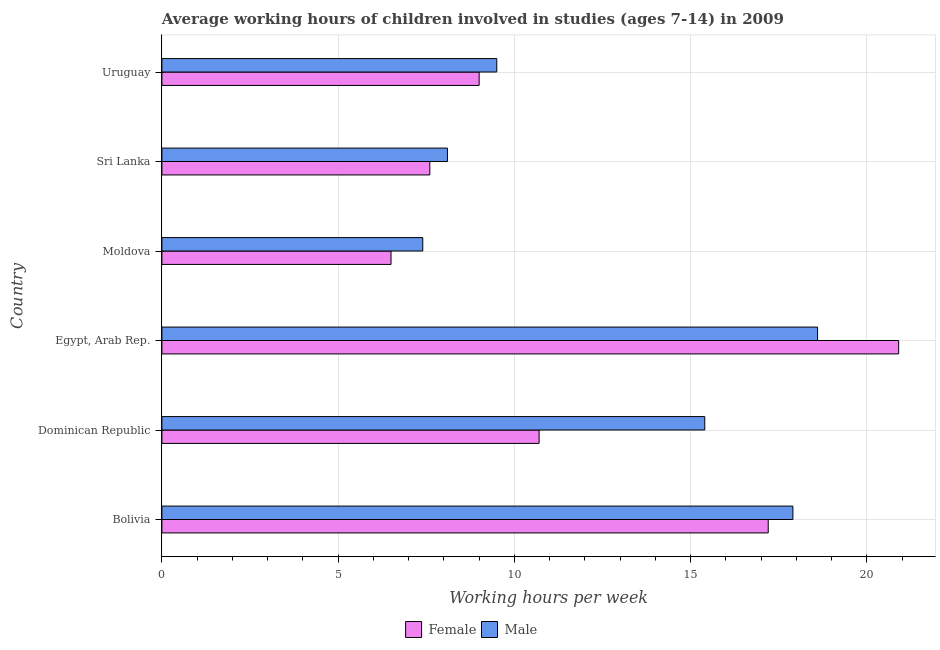How many different coloured bars are there?
Your answer should be compact. 2. Are the number of bars on each tick of the Y-axis equal?
Offer a terse response. Yes. What is the label of the 1st group of bars from the top?
Your answer should be compact. Uruguay. In how many cases, is the number of bars for a given country not equal to the number of legend labels?
Give a very brief answer. 0. Across all countries, what is the maximum average working hour of male children?
Give a very brief answer. 18.6. In which country was the average working hour of male children maximum?
Provide a succinct answer. Egypt, Arab Rep. In which country was the average working hour of female children minimum?
Your response must be concise. Moldova. What is the total average working hour of male children in the graph?
Your answer should be very brief. 76.9. What is the difference between the average working hour of male children in Dominican Republic and the average working hour of female children in Uruguay?
Keep it short and to the point. 6.4. What is the average average working hour of male children per country?
Your answer should be compact. 12.82. What is the difference between the average working hour of male children and average working hour of female children in Bolivia?
Offer a very short reply. 0.7. What is the ratio of the average working hour of male children in Moldova to that in Uruguay?
Your answer should be very brief. 0.78. What is the difference between the highest and the lowest average working hour of male children?
Your answer should be compact. 11.2. Is the sum of the average working hour of female children in Egypt, Arab Rep. and Moldova greater than the maximum average working hour of male children across all countries?
Ensure brevity in your answer.  Yes. What does the 2nd bar from the bottom in Egypt, Arab Rep. represents?
Your answer should be compact. Male. How many bars are there?
Your answer should be very brief. 12. How many countries are there in the graph?
Offer a very short reply. 6. What is the difference between two consecutive major ticks on the X-axis?
Ensure brevity in your answer.  5. Does the graph contain any zero values?
Your answer should be compact. No. Does the graph contain grids?
Your response must be concise. Yes. How many legend labels are there?
Make the answer very short. 2. What is the title of the graph?
Provide a succinct answer. Average working hours of children involved in studies (ages 7-14) in 2009. What is the label or title of the X-axis?
Your answer should be very brief. Working hours per week. What is the Working hours per week in Female in Bolivia?
Make the answer very short. 17.2. What is the Working hours per week in Female in Dominican Republic?
Provide a short and direct response. 10.7. What is the Working hours per week of Female in Egypt, Arab Rep.?
Keep it short and to the point. 20.9. What is the Working hours per week in Male in Egypt, Arab Rep.?
Provide a short and direct response. 18.6. What is the Working hours per week of Female in Moldova?
Your answer should be compact. 6.5. What is the Working hours per week in Male in Uruguay?
Your response must be concise. 9.5. Across all countries, what is the maximum Working hours per week of Female?
Give a very brief answer. 20.9. Across all countries, what is the maximum Working hours per week in Male?
Ensure brevity in your answer.  18.6. What is the total Working hours per week of Female in the graph?
Your answer should be compact. 71.9. What is the total Working hours per week of Male in the graph?
Provide a short and direct response. 76.9. What is the difference between the Working hours per week of Male in Bolivia and that in Dominican Republic?
Make the answer very short. 2.5. What is the difference between the Working hours per week of Female in Bolivia and that in Egypt, Arab Rep.?
Provide a succinct answer. -3.7. What is the difference between the Working hours per week of Male in Bolivia and that in Moldova?
Offer a terse response. 10.5. What is the difference between the Working hours per week in Female in Bolivia and that in Sri Lanka?
Ensure brevity in your answer.  9.6. What is the difference between the Working hours per week in Male in Bolivia and that in Sri Lanka?
Your response must be concise. 9.8. What is the difference between the Working hours per week in Female in Bolivia and that in Uruguay?
Your response must be concise. 8.2. What is the difference between the Working hours per week of Female in Dominican Republic and that in Uruguay?
Offer a terse response. 1.7. What is the difference between the Working hours per week of Female in Egypt, Arab Rep. and that in Moldova?
Make the answer very short. 14.4. What is the difference between the Working hours per week in Male in Egypt, Arab Rep. and that in Sri Lanka?
Provide a succinct answer. 10.5. What is the difference between the Working hours per week in Female in Egypt, Arab Rep. and that in Uruguay?
Provide a succinct answer. 11.9. What is the difference between the Working hours per week in Male in Egypt, Arab Rep. and that in Uruguay?
Keep it short and to the point. 9.1. What is the difference between the Working hours per week in Female in Moldova and that in Sri Lanka?
Offer a very short reply. -1.1. What is the difference between the Working hours per week in Male in Moldova and that in Sri Lanka?
Offer a very short reply. -0.7. What is the difference between the Working hours per week of Male in Moldova and that in Uruguay?
Offer a very short reply. -2.1. What is the difference between the Working hours per week in Female in Sri Lanka and that in Uruguay?
Your response must be concise. -1.4. What is the difference between the Working hours per week of Female in Bolivia and the Working hours per week of Male in Dominican Republic?
Provide a succinct answer. 1.8. What is the difference between the Working hours per week in Female in Bolivia and the Working hours per week in Male in Uruguay?
Make the answer very short. 7.7. What is the difference between the Working hours per week in Female in Dominican Republic and the Working hours per week in Male in Sri Lanka?
Offer a terse response. 2.6. What is the difference between the Working hours per week of Female in Egypt, Arab Rep. and the Working hours per week of Male in Moldova?
Provide a short and direct response. 13.5. What is the difference between the Working hours per week of Female in Egypt, Arab Rep. and the Working hours per week of Male in Sri Lanka?
Provide a short and direct response. 12.8. What is the difference between the Working hours per week of Female in Egypt, Arab Rep. and the Working hours per week of Male in Uruguay?
Your answer should be compact. 11.4. What is the difference between the Working hours per week in Female in Moldova and the Working hours per week in Male in Sri Lanka?
Offer a terse response. -1.6. What is the difference between the Working hours per week in Female in Moldova and the Working hours per week in Male in Uruguay?
Provide a short and direct response. -3. What is the average Working hours per week in Female per country?
Give a very brief answer. 11.98. What is the average Working hours per week in Male per country?
Offer a terse response. 12.82. What is the difference between the Working hours per week in Female and Working hours per week in Male in Dominican Republic?
Offer a very short reply. -4.7. What is the difference between the Working hours per week in Female and Working hours per week in Male in Sri Lanka?
Your answer should be very brief. -0.5. What is the difference between the Working hours per week in Female and Working hours per week in Male in Uruguay?
Provide a short and direct response. -0.5. What is the ratio of the Working hours per week in Female in Bolivia to that in Dominican Republic?
Your answer should be very brief. 1.61. What is the ratio of the Working hours per week of Male in Bolivia to that in Dominican Republic?
Provide a succinct answer. 1.16. What is the ratio of the Working hours per week of Female in Bolivia to that in Egypt, Arab Rep.?
Provide a short and direct response. 0.82. What is the ratio of the Working hours per week in Male in Bolivia to that in Egypt, Arab Rep.?
Provide a succinct answer. 0.96. What is the ratio of the Working hours per week in Female in Bolivia to that in Moldova?
Your response must be concise. 2.65. What is the ratio of the Working hours per week of Male in Bolivia to that in Moldova?
Make the answer very short. 2.42. What is the ratio of the Working hours per week of Female in Bolivia to that in Sri Lanka?
Offer a very short reply. 2.26. What is the ratio of the Working hours per week in Male in Bolivia to that in Sri Lanka?
Your answer should be compact. 2.21. What is the ratio of the Working hours per week of Female in Bolivia to that in Uruguay?
Keep it short and to the point. 1.91. What is the ratio of the Working hours per week in Male in Bolivia to that in Uruguay?
Offer a very short reply. 1.88. What is the ratio of the Working hours per week of Female in Dominican Republic to that in Egypt, Arab Rep.?
Offer a very short reply. 0.51. What is the ratio of the Working hours per week of Male in Dominican Republic to that in Egypt, Arab Rep.?
Offer a terse response. 0.83. What is the ratio of the Working hours per week in Female in Dominican Republic to that in Moldova?
Give a very brief answer. 1.65. What is the ratio of the Working hours per week in Male in Dominican Republic to that in Moldova?
Ensure brevity in your answer.  2.08. What is the ratio of the Working hours per week in Female in Dominican Republic to that in Sri Lanka?
Provide a succinct answer. 1.41. What is the ratio of the Working hours per week in Male in Dominican Republic to that in Sri Lanka?
Your answer should be very brief. 1.9. What is the ratio of the Working hours per week of Female in Dominican Republic to that in Uruguay?
Your response must be concise. 1.19. What is the ratio of the Working hours per week of Male in Dominican Republic to that in Uruguay?
Your answer should be very brief. 1.62. What is the ratio of the Working hours per week in Female in Egypt, Arab Rep. to that in Moldova?
Keep it short and to the point. 3.22. What is the ratio of the Working hours per week in Male in Egypt, Arab Rep. to that in Moldova?
Your answer should be compact. 2.51. What is the ratio of the Working hours per week in Female in Egypt, Arab Rep. to that in Sri Lanka?
Ensure brevity in your answer.  2.75. What is the ratio of the Working hours per week of Male in Egypt, Arab Rep. to that in Sri Lanka?
Offer a terse response. 2.3. What is the ratio of the Working hours per week in Female in Egypt, Arab Rep. to that in Uruguay?
Provide a short and direct response. 2.32. What is the ratio of the Working hours per week of Male in Egypt, Arab Rep. to that in Uruguay?
Ensure brevity in your answer.  1.96. What is the ratio of the Working hours per week of Female in Moldova to that in Sri Lanka?
Make the answer very short. 0.86. What is the ratio of the Working hours per week in Male in Moldova to that in Sri Lanka?
Provide a short and direct response. 0.91. What is the ratio of the Working hours per week of Female in Moldova to that in Uruguay?
Offer a terse response. 0.72. What is the ratio of the Working hours per week in Male in Moldova to that in Uruguay?
Offer a very short reply. 0.78. What is the ratio of the Working hours per week in Female in Sri Lanka to that in Uruguay?
Your answer should be very brief. 0.84. What is the ratio of the Working hours per week in Male in Sri Lanka to that in Uruguay?
Make the answer very short. 0.85. What is the difference between the highest and the lowest Working hours per week of Female?
Provide a short and direct response. 14.4. 